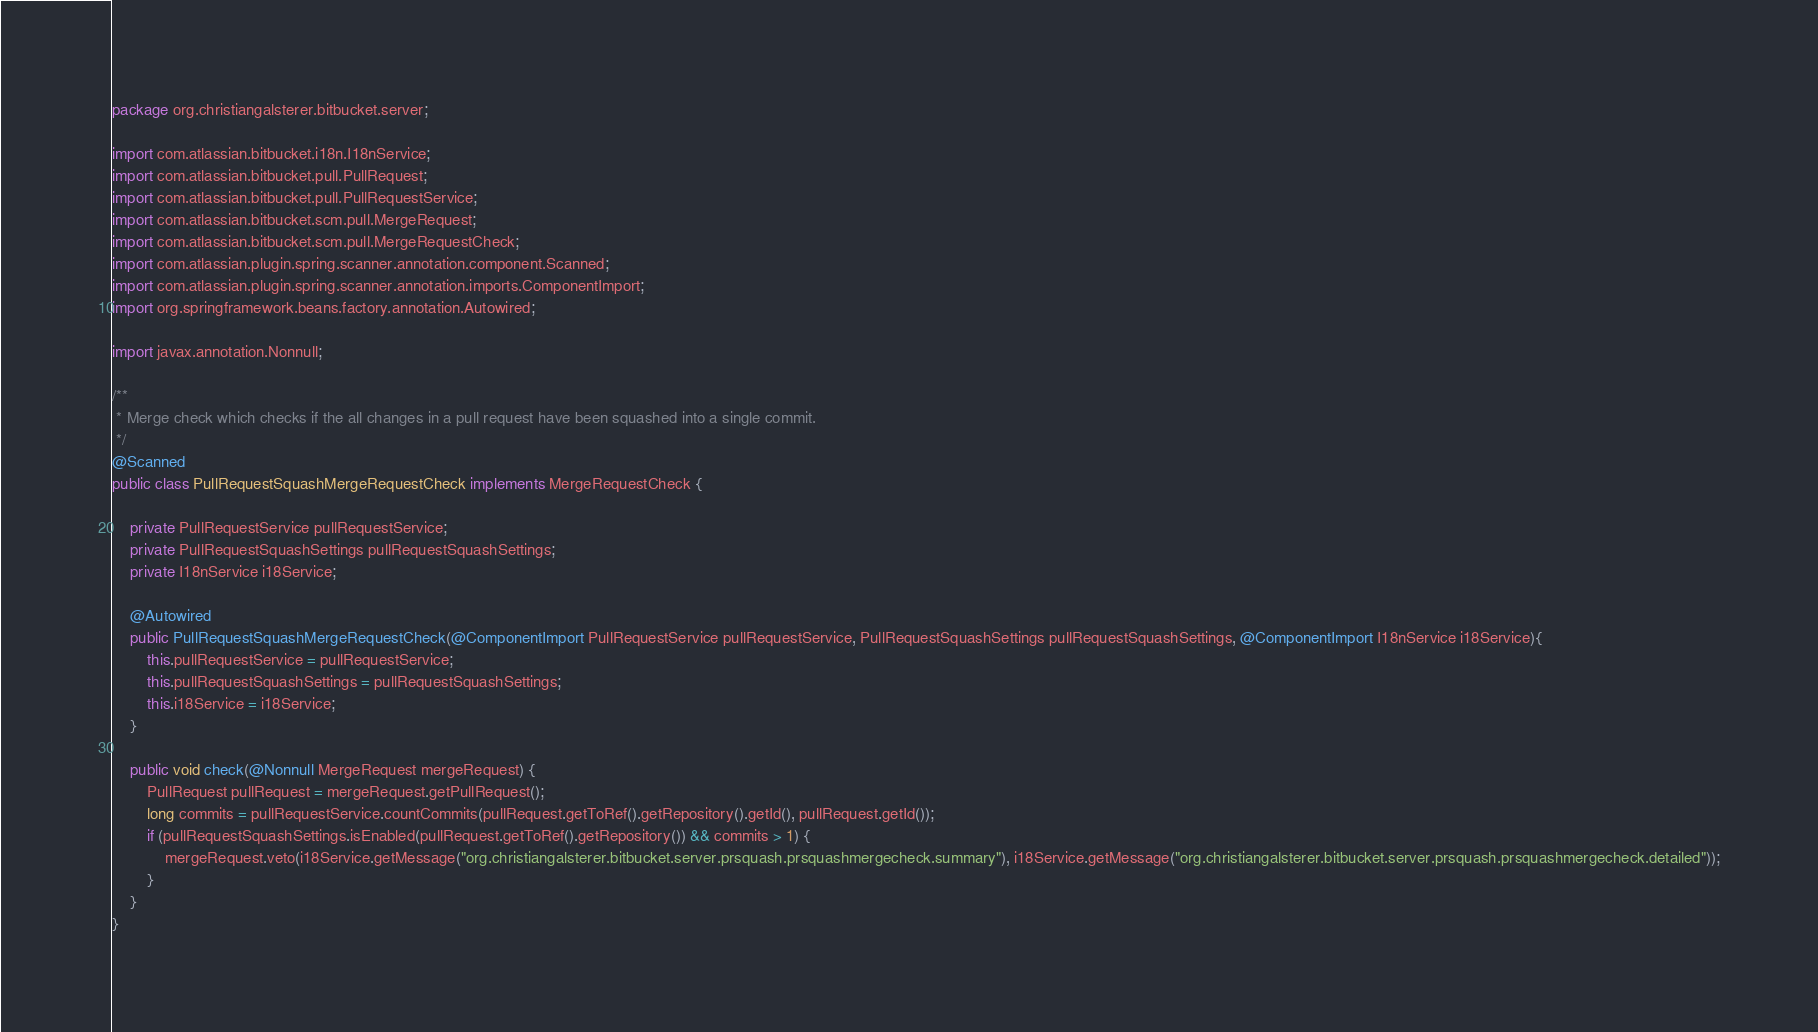<code> <loc_0><loc_0><loc_500><loc_500><_Java_>package org.christiangalsterer.bitbucket.server;

import com.atlassian.bitbucket.i18n.I18nService;
import com.atlassian.bitbucket.pull.PullRequest;
import com.atlassian.bitbucket.pull.PullRequestService;
import com.atlassian.bitbucket.scm.pull.MergeRequest;
import com.atlassian.bitbucket.scm.pull.MergeRequestCheck;
import com.atlassian.plugin.spring.scanner.annotation.component.Scanned;
import com.atlassian.plugin.spring.scanner.annotation.imports.ComponentImport;
import org.springframework.beans.factory.annotation.Autowired;

import javax.annotation.Nonnull;

/**
 * Merge check which checks if the all changes in a pull request have been squashed into a single commit.
 */
@Scanned
public class PullRequestSquashMergeRequestCheck implements MergeRequestCheck {

    private PullRequestService pullRequestService;
    private PullRequestSquashSettings pullRequestSquashSettings;
    private I18nService i18Service;

    @Autowired
    public PullRequestSquashMergeRequestCheck(@ComponentImport PullRequestService pullRequestService, PullRequestSquashSettings pullRequestSquashSettings, @ComponentImport I18nService i18Service){
        this.pullRequestService = pullRequestService;
        this.pullRequestSquashSettings = pullRequestSquashSettings;
        this.i18Service = i18Service;
    }

    public void check(@Nonnull MergeRequest mergeRequest) {
        PullRequest pullRequest = mergeRequest.getPullRequest();
        long commits = pullRequestService.countCommits(pullRequest.getToRef().getRepository().getId(), pullRequest.getId());
        if (pullRequestSquashSettings.isEnabled(pullRequest.getToRef().getRepository()) && commits > 1) {
            mergeRequest.veto(i18Service.getMessage("org.christiangalsterer.bitbucket.server.prsquash.prsquashmergecheck.summary"), i18Service.getMessage("org.christiangalsterer.bitbucket.server.prsquash.prsquashmergecheck.detailed"));
        }
    }
}
</code> 